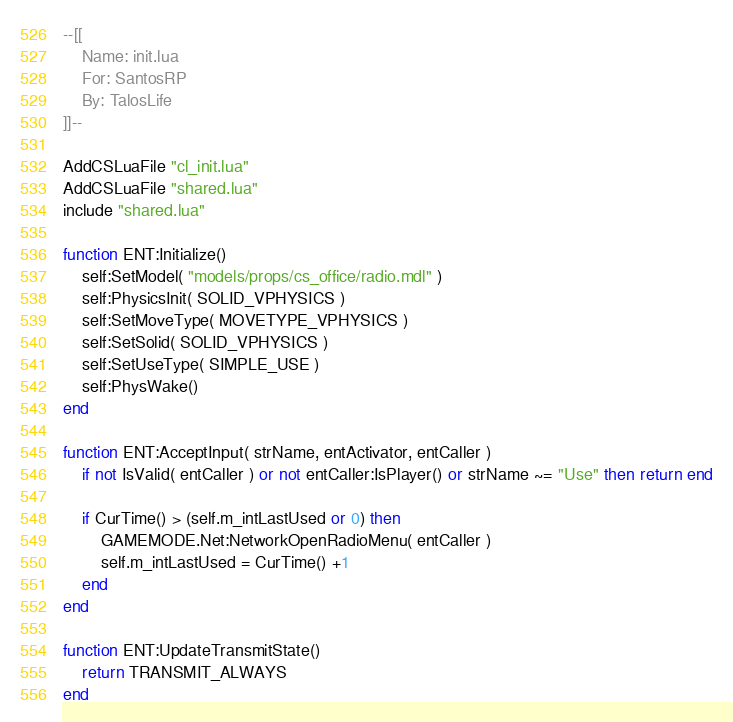Convert code to text. <code><loc_0><loc_0><loc_500><loc_500><_Lua_>--[[
	Name: init.lua
	For: SantosRP
	By: TalosLife
]]--

AddCSLuaFile "cl_init.lua"
AddCSLuaFile "shared.lua"
include "shared.lua"

function ENT:Initialize()
	self:SetModel( "models/props/cs_office/radio.mdl" )
	self:PhysicsInit( SOLID_VPHYSICS )
	self:SetMoveType( MOVETYPE_VPHYSICS )
	self:SetSolid( SOLID_VPHYSICS )
	self:SetUseType( SIMPLE_USE )
	self:PhysWake()
end

function ENT:AcceptInput( strName, entActivator, entCaller )
	if not IsValid( entCaller ) or not entCaller:IsPlayer() or strName ~= "Use" then return end

	if CurTime() > (self.m_intLastUsed or 0) then
		GAMEMODE.Net:NetworkOpenRadioMenu( entCaller )
		self.m_intLastUsed = CurTime() +1
	end
end

function ENT:UpdateTransmitState()
	return TRANSMIT_ALWAYS
end</code> 